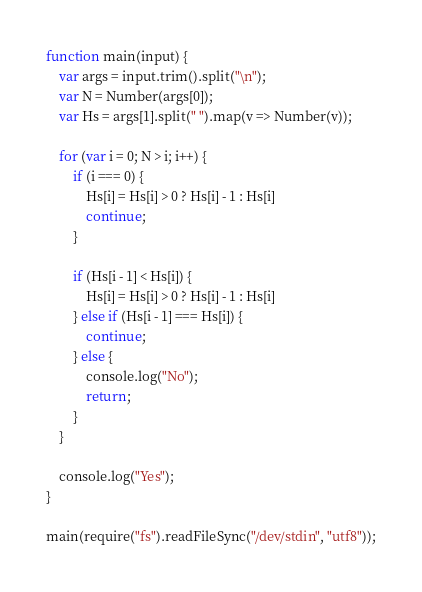<code> <loc_0><loc_0><loc_500><loc_500><_JavaScript_>function main(input) {
    var args = input.trim().split("\n");
    var N = Number(args[0]);
    var Hs = args[1].split(" ").map(v => Number(v));

    for (var i = 0; N > i; i++) {
        if (i === 0) {
            Hs[i] = Hs[i] > 0 ? Hs[i] - 1 : Hs[i]
            continue;
        }

        if (Hs[i - 1] < Hs[i]) {
            Hs[i] = Hs[i] > 0 ? Hs[i] - 1 : Hs[i]
        } else if (Hs[i - 1] === Hs[i]) {
            continue;
        } else {
            console.log("No");
            return;
        }
    }

    console.log("Yes");
}

main(require("fs").readFileSync("/dev/stdin", "utf8"));</code> 